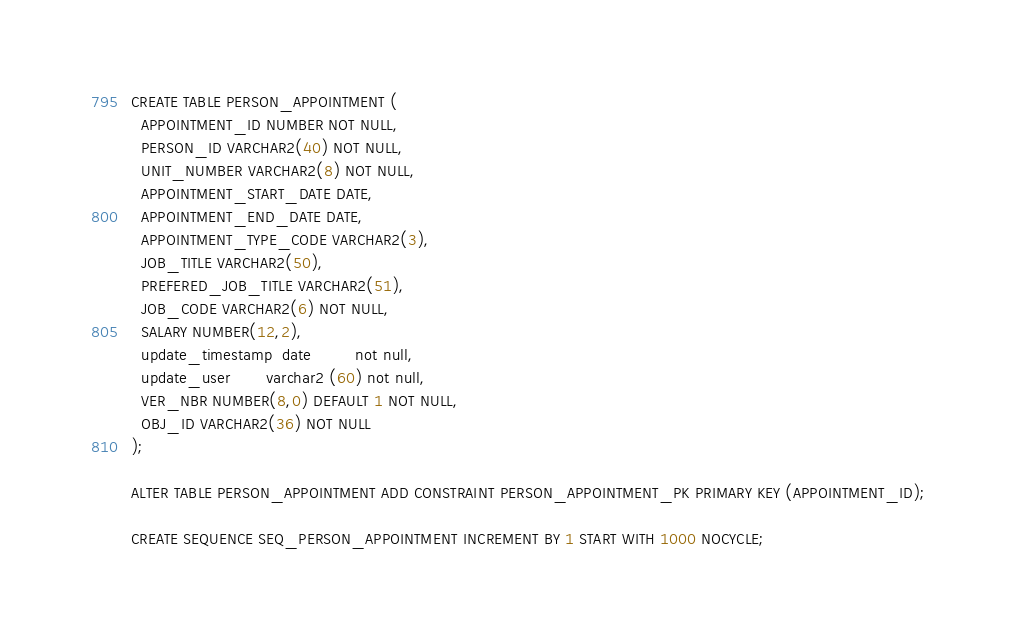<code> <loc_0><loc_0><loc_500><loc_500><_SQL_>CREATE TABLE PERSON_APPOINTMENT (
  APPOINTMENT_ID NUMBER NOT NULL,
  PERSON_ID VARCHAR2(40) NOT NULL,
  UNIT_NUMBER VARCHAR2(8) NOT NULL,
  APPOINTMENT_START_DATE DATE,
  APPOINTMENT_END_DATE DATE,
  APPOINTMENT_TYPE_CODE VARCHAR2(3),
  JOB_TITLE VARCHAR2(50),
  PREFERED_JOB_TITLE VARCHAR2(51),
  JOB_CODE VARCHAR2(6) NOT NULL,
  SALARY NUMBER(12,2),
  update_timestamp  date         not null,
  update_user       varchar2 (60) not null,
  VER_NBR NUMBER(8,0) DEFAULT 1 NOT NULL,
  OBJ_ID VARCHAR2(36) NOT NULL
);

ALTER TABLE PERSON_APPOINTMENT ADD CONSTRAINT PERSON_APPOINTMENT_PK PRIMARY KEY (APPOINTMENT_ID);

CREATE SEQUENCE SEQ_PERSON_APPOINTMENT INCREMENT BY 1 START WITH 1000 NOCYCLE;</code> 